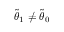<formula> <loc_0><loc_0><loc_500><loc_500>\tilde { \theta } _ { 1 } \neq \tilde { \theta } _ { 0 }</formula> 